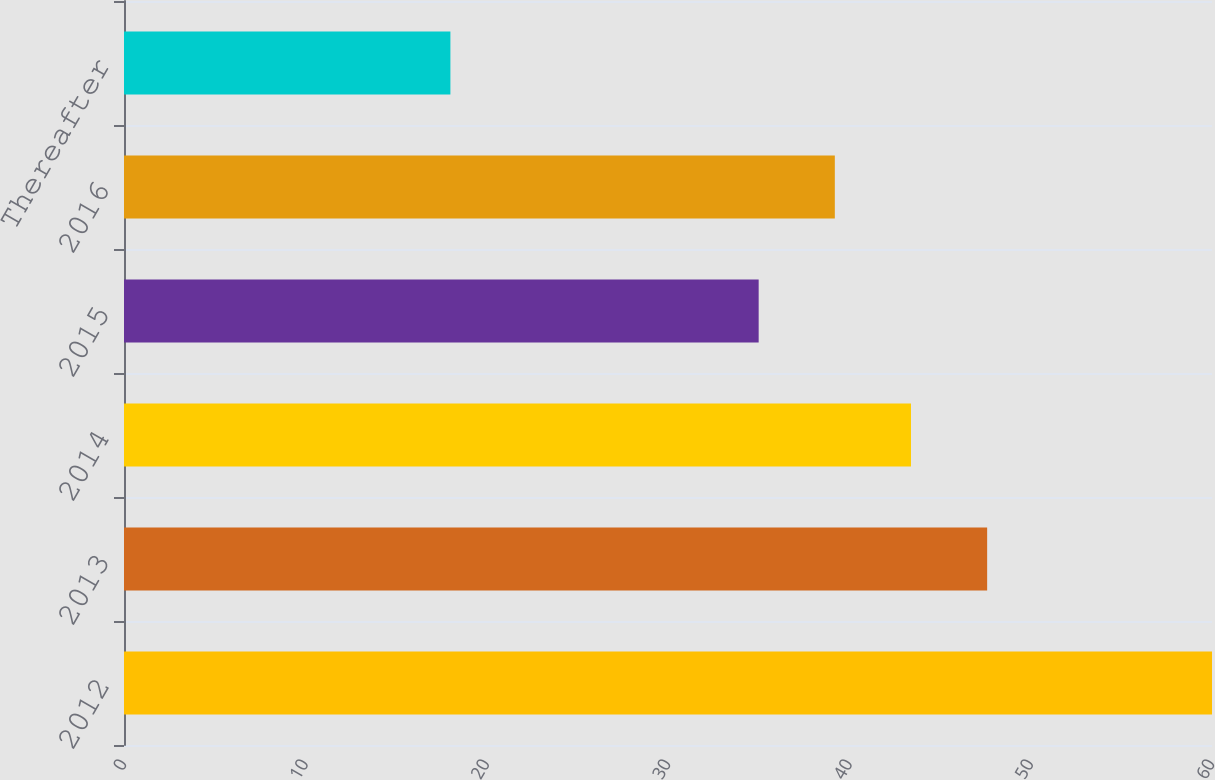<chart> <loc_0><loc_0><loc_500><loc_500><bar_chart><fcel>2012<fcel>2013<fcel>2014<fcel>2015<fcel>2016<fcel>Thereafter<nl><fcel>60<fcel>47.6<fcel>43.4<fcel>35<fcel>39.2<fcel>18<nl></chart> 